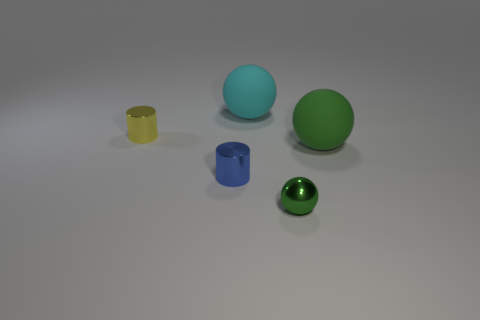There is a big rubber sphere that is left of the large green object; what is its color?
Give a very brief answer. Cyan. What is the material of the big object that is the same color as the shiny ball?
Provide a short and direct response. Rubber. Are there any small blue shiny cylinders in front of the tiny blue thing?
Ensure brevity in your answer.  No. Is the number of tiny red rubber spheres greater than the number of large green matte things?
Offer a very short reply. No. There is a tiny shiny thing that is behind the tiny metallic cylinder in front of the tiny shiny cylinder that is behind the large green matte thing; what color is it?
Keep it short and to the point. Yellow. What color is the other cylinder that is made of the same material as the blue cylinder?
Ensure brevity in your answer.  Yellow. Is there anything else that has the same size as the green metal ball?
Give a very brief answer. Yes. What number of things are either small metal things that are behind the blue object or blue cylinders left of the big green rubber sphere?
Make the answer very short. 2. Do the matte ball that is to the right of the cyan ball and the shiny thing on the right side of the cyan rubber ball have the same size?
Offer a very short reply. No. There is another matte object that is the same shape as the big green matte object; what is its color?
Provide a short and direct response. Cyan. 